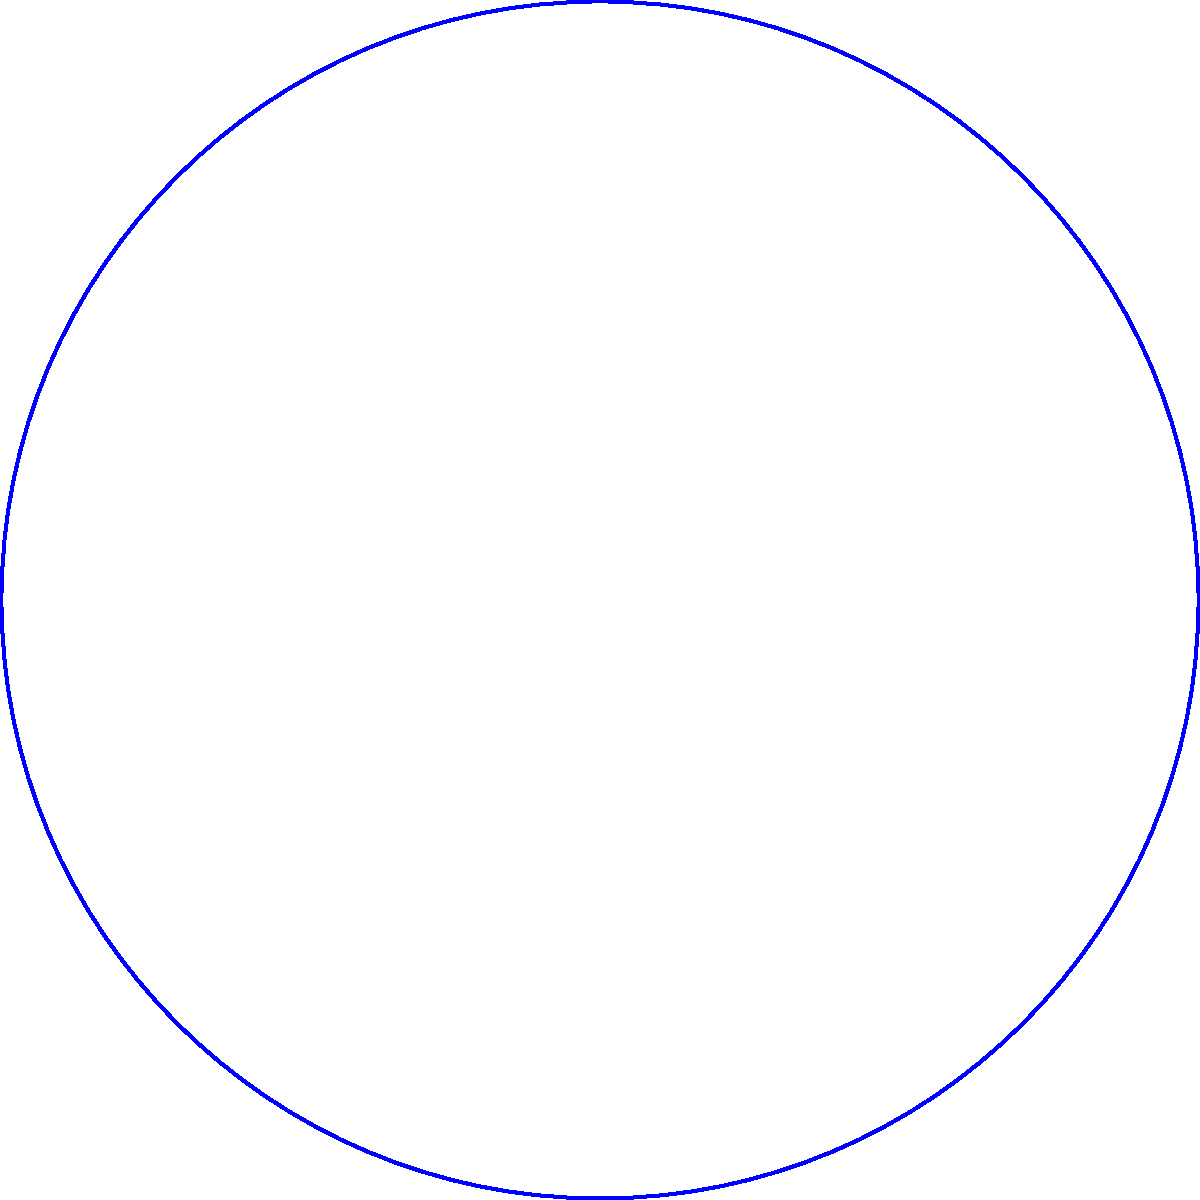In your circular beer barrel storage area, you've arranged three types of barrels (A, B, and C) in equal sectors on the floor, as shown in the diagram. If the radius of the storage area is 5 meters, what is the length of the arc (in meters) that separates barrel types A and B on the floor? Round your answer to two decimal places. To solve this problem, we'll use concepts from spherical geometry applied to a circular floor plan:

1) First, we need to identify the central angle of each sector. Since there are three equal sectors, each central angle is $360^\circ \div 3 = 120^\circ$.

2) The arc length formula for a circle is:
   
   $s = r\theta$

   Where:
   $s$ is the arc length
   $r$ is the radius
   $\theta$ is the central angle in radians

3) We need to convert the central angle from degrees to radians:
   
   $120^\circ \times \frac{\pi}{180^\circ} = \frac{2\pi}{3}$ radians

4) Now we can plug these values into the arc length formula:

   $s = 5 \times \frac{2\pi}{3}$

5) Simplify:
   
   $s = \frac{10\pi}{3}$ meters

6) Calculate and round to two decimal places:
   
   $s \approx 10.47$ meters
Answer: 10.47 meters 